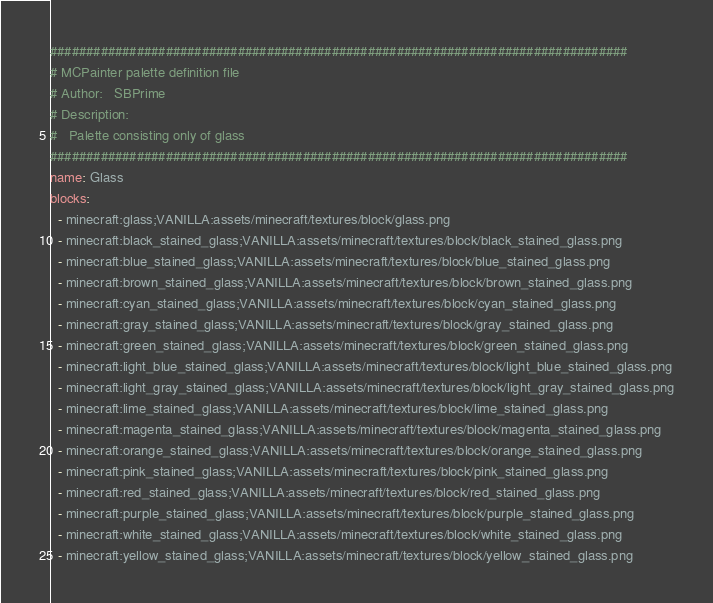Convert code to text. <code><loc_0><loc_0><loc_500><loc_500><_YAML_>################################################################################
# MCPainter palette definition file
# Author:   SBPrime
# Description:
#   Palette consisting only of glass
################################################################################
name: Glass
blocks:
  - minecraft:glass;VANILLA:assets/minecraft/textures/block/glass.png
  - minecraft:black_stained_glass;VANILLA:assets/minecraft/textures/block/black_stained_glass.png
  - minecraft:blue_stained_glass;VANILLA:assets/minecraft/textures/block/blue_stained_glass.png
  - minecraft:brown_stained_glass;VANILLA:assets/minecraft/textures/block/brown_stained_glass.png
  - minecraft:cyan_stained_glass;VANILLA:assets/minecraft/textures/block/cyan_stained_glass.png
  - minecraft:gray_stained_glass;VANILLA:assets/minecraft/textures/block/gray_stained_glass.png
  - minecraft:green_stained_glass;VANILLA:assets/minecraft/textures/block/green_stained_glass.png
  - minecraft:light_blue_stained_glass;VANILLA:assets/minecraft/textures/block/light_blue_stained_glass.png
  - minecraft:light_gray_stained_glass;VANILLA:assets/minecraft/textures/block/light_gray_stained_glass.png
  - minecraft:lime_stained_glass;VANILLA:assets/minecraft/textures/block/lime_stained_glass.png
  - minecraft:magenta_stained_glass;VANILLA:assets/minecraft/textures/block/magenta_stained_glass.png
  - minecraft:orange_stained_glass;VANILLA:assets/minecraft/textures/block/orange_stained_glass.png
  - minecraft:pink_stained_glass;VANILLA:assets/minecraft/textures/block/pink_stained_glass.png
  - minecraft:red_stained_glass;VANILLA:assets/minecraft/textures/block/red_stained_glass.png
  - minecraft:purple_stained_glass;VANILLA:assets/minecraft/textures/block/purple_stained_glass.png
  - minecraft:white_stained_glass;VANILLA:assets/minecraft/textures/block/white_stained_glass.png
  - minecraft:yellow_stained_glass;VANILLA:assets/minecraft/textures/block/yellow_stained_glass.png</code> 